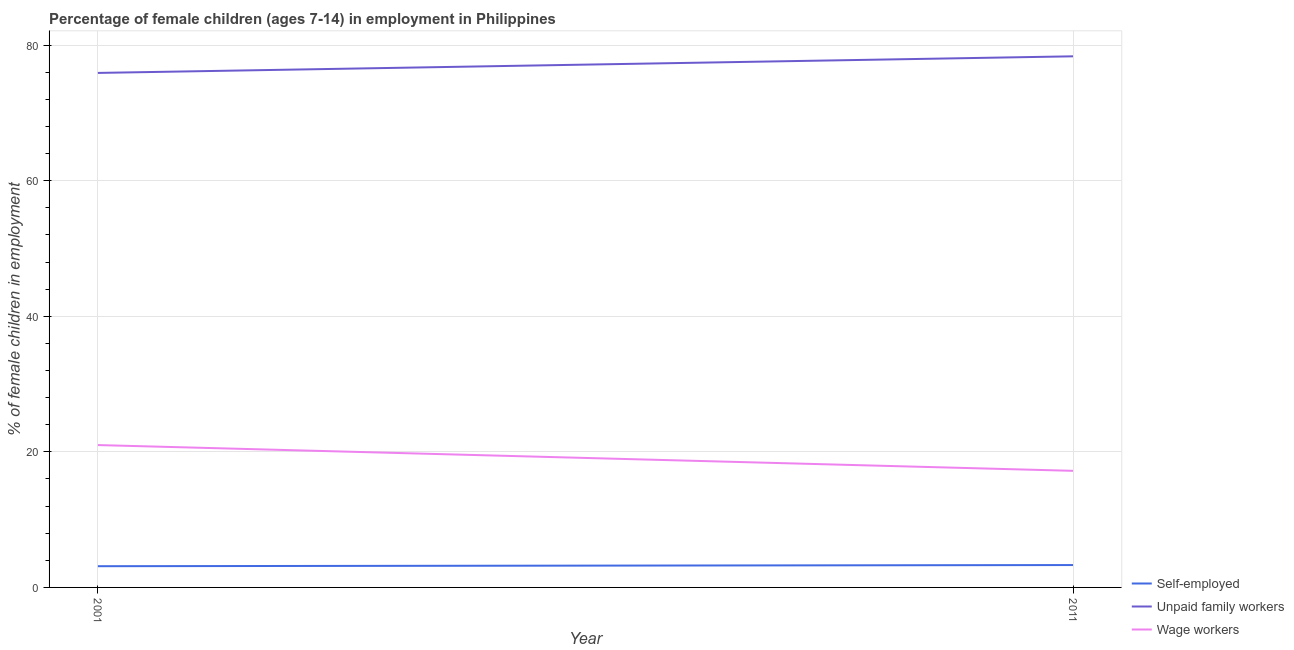What is the percentage of children employed as unpaid family workers in 2001?
Offer a very short reply. 75.9. Across all years, what is the maximum percentage of self employed children?
Provide a succinct answer. 3.3. What is the total percentage of children employed as unpaid family workers in the graph?
Ensure brevity in your answer.  154.25. What is the difference between the percentage of children employed as wage workers in 2001 and that in 2011?
Provide a succinct answer. 3.8. What is the difference between the percentage of children employed as unpaid family workers in 2011 and the percentage of self employed children in 2001?
Your answer should be very brief. 75.22. What is the average percentage of self employed children per year?
Your answer should be compact. 3.21. In the year 2011, what is the difference between the percentage of children employed as wage workers and percentage of self employed children?
Provide a succinct answer. 13.9. In how many years, is the percentage of children employed as unpaid family workers greater than 64 %?
Provide a succinct answer. 2. What is the ratio of the percentage of children employed as unpaid family workers in 2001 to that in 2011?
Offer a terse response. 0.97. Is it the case that in every year, the sum of the percentage of self employed children and percentage of children employed as unpaid family workers is greater than the percentage of children employed as wage workers?
Provide a succinct answer. Yes. Does the percentage of children employed as wage workers monotonically increase over the years?
Offer a terse response. No. Is the percentage of self employed children strictly greater than the percentage of children employed as unpaid family workers over the years?
Offer a very short reply. No. Is the percentage of self employed children strictly less than the percentage of children employed as unpaid family workers over the years?
Provide a short and direct response. Yes. How many years are there in the graph?
Ensure brevity in your answer.  2. What is the difference between two consecutive major ticks on the Y-axis?
Provide a short and direct response. 20. Are the values on the major ticks of Y-axis written in scientific E-notation?
Keep it short and to the point. No. Does the graph contain any zero values?
Make the answer very short. No. Where does the legend appear in the graph?
Keep it short and to the point. Bottom right. How are the legend labels stacked?
Offer a very short reply. Vertical. What is the title of the graph?
Give a very brief answer. Percentage of female children (ages 7-14) in employment in Philippines. What is the label or title of the X-axis?
Provide a succinct answer. Year. What is the label or title of the Y-axis?
Offer a very short reply. % of female children in employment. What is the % of female children in employment of Self-employed in 2001?
Your answer should be compact. 3.13. What is the % of female children in employment in Unpaid family workers in 2001?
Ensure brevity in your answer.  75.9. What is the % of female children in employment of Wage workers in 2001?
Give a very brief answer. 21. What is the % of female children in employment of Self-employed in 2011?
Your response must be concise. 3.3. What is the % of female children in employment of Unpaid family workers in 2011?
Your answer should be very brief. 78.35. What is the % of female children in employment of Wage workers in 2011?
Provide a succinct answer. 17.2. Across all years, what is the maximum % of female children in employment in Self-employed?
Your answer should be very brief. 3.3. Across all years, what is the maximum % of female children in employment of Unpaid family workers?
Ensure brevity in your answer.  78.35. Across all years, what is the maximum % of female children in employment of Wage workers?
Provide a short and direct response. 21. Across all years, what is the minimum % of female children in employment in Self-employed?
Ensure brevity in your answer.  3.13. Across all years, what is the minimum % of female children in employment of Unpaid family workers?
Offer a terse response. 75.9. What is the total % of female children in employment of Self-employed in the graph?
Give a very brief answer. 6.43. What is the total % of female children in employment of Unpaid family workers in the graph?
Provide a short and direct response. 154.25. What is the total % of female children in employment of Wage workers in the graph?
Offer a very short reply. 38.2. What is the difference between the % of female children in employment in Self-employed in 2001 and that in 2011?
Give a very brief answer. -0.17. What is the difference between the % of female children in employment in Unpaid family workers in 2001 and that in 2011?
Ensure brevity in your answer.  -2.45. What is the difference between the % of female children in employment of Self-employed in 2001 and the % of female children in employment of Unpaid family workers in 2011?
Your response must be concise. -75.22. What is the difference between the % of female children in employment of Self-employed in 2001 and the % of female children in employment of Wage workers in 2011?
Keep it short and to the point. -14.07. What is the difference between the % of female children in employment of Unpaid family workers in 2001 and the % of female children in employment of Wage workers in 2011?
Your answer should be very brief. 58.7. What is the average % of female children in employment of Self-employed per year?
Give a very brief answer. 3.21. What is the average % of female children in employment of Unpaid family workers per year?
Offer a very short reply. 77.12. In the year 2001, what is the difference between the % of female children in employment of Self-employed and % of female children in employment of Unpaid family workers?
Provide a short and direct response. -72.77. In the year 2001, what is the difference between the % of female children in employment of Self-employed and % of female children in employment of Wage workers?
Ensure brevity in your answer.  -17.87. In the year 2001, what is the difference between the % of female children in employment in Unpaid family workers and % of female children in employment in Wage workers?
Offer a terse response. 54.9. In the year 2011, what is the difference between the % of female children in employment in Self-employed and % of female children in employment in Unpaid family workers?
Make the answer very short. -75.05. In the year 2011, what is the difference between the % of female children in employment in Unpaid family workers and % of female children in employment in Wage workers?
Ensure brevity in your answer.  61.15. What is the ratio of the % of female children in employment of Self-employed in 2001 to that in 2011?
Offer a very short reply. 0.95. What is the ratio of the % of female children in employment in Unpaid family workers in 2001 to that in 2011?
Keep it short and to the point. 0.97. What is the ratio of the % of female children in employment of Wage workers in 2001 to that in 2011?
Ensure brevity in your answer.  1.22. What is the difference between the highest and the second highest % of female children in employment of Self-employed?
Keep it short and to the point. 0.17. What is the difference between the highest and the second highest % of female children in employment in Unpaid family workers?
Make the answer very short. 2.45. What is the difference between the highest and the second highest % of female children in employment of Wage workers?
Your answer should be compact. 3.8. What is the difference between the highest and the lowest % of female children in employment in Self-employed?
Your answer should be very brief. 0.17. What is the difference between the highest and the lowest % of female children in employment of Unpaid family workers?
Your answer should be compact. 2.45. What is the difference between the highest and the lowest % of female children in employment in Wage workers?
Keep it short and to the point. 3.8. 